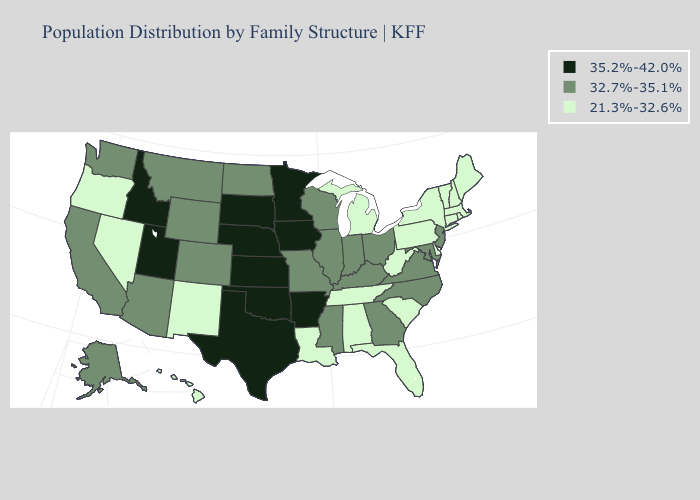What is the value of South Carolina?
Answer briefly. 21.3%-32.6%. Among the states that border Nevada , does California have the lowest value?
Give a very brief answer. No. What is the lowest value in the Northeast?
Be succinct. 21.3%-32.6%. What is the value of Oregon?
Short answer required. 21.3%-32.6%. How many symbols are there in the legend?
Quick response, please. 3. What is the value of North Carolina?
Write a very short answer. 32.7%-35.1%. What is the highest value in states that border Mississippi?
Answer briefly. 35.2%-42.0%. Name the states that have a value in the range 21.3%-32.6%?
Short answer required. Alabama, Connecticut, Delaware, Florida, Hawaii, Louisiana, Maine, Massachusetts, Michigan, Nevada, New Hampshire, New Mexico, New York, Oregon, Pennsylvania, Rhode Island, South Carolina, Tennessee, Vermont, West Virginia. Does Oklahoma have the highest value in the USA?
Concise answer only. Yes. What is the value of California?
Give a very brief answer. 32.7%-35.1%. What is the value of New Mexico?
Answer briefly. 21.3%-32.6%. What is the lowest value in states that border New Jersey?
Be succinct. 21.3%-32.6%. Which states have the lowest value in the MidWest?
Concise answer only. Michigan. What is the value of Kentucky?
Concise answer only. 32.7%-35.1%. What is the lowest value in the South?
Give a very brief answer. 21.3%-32.6%. 